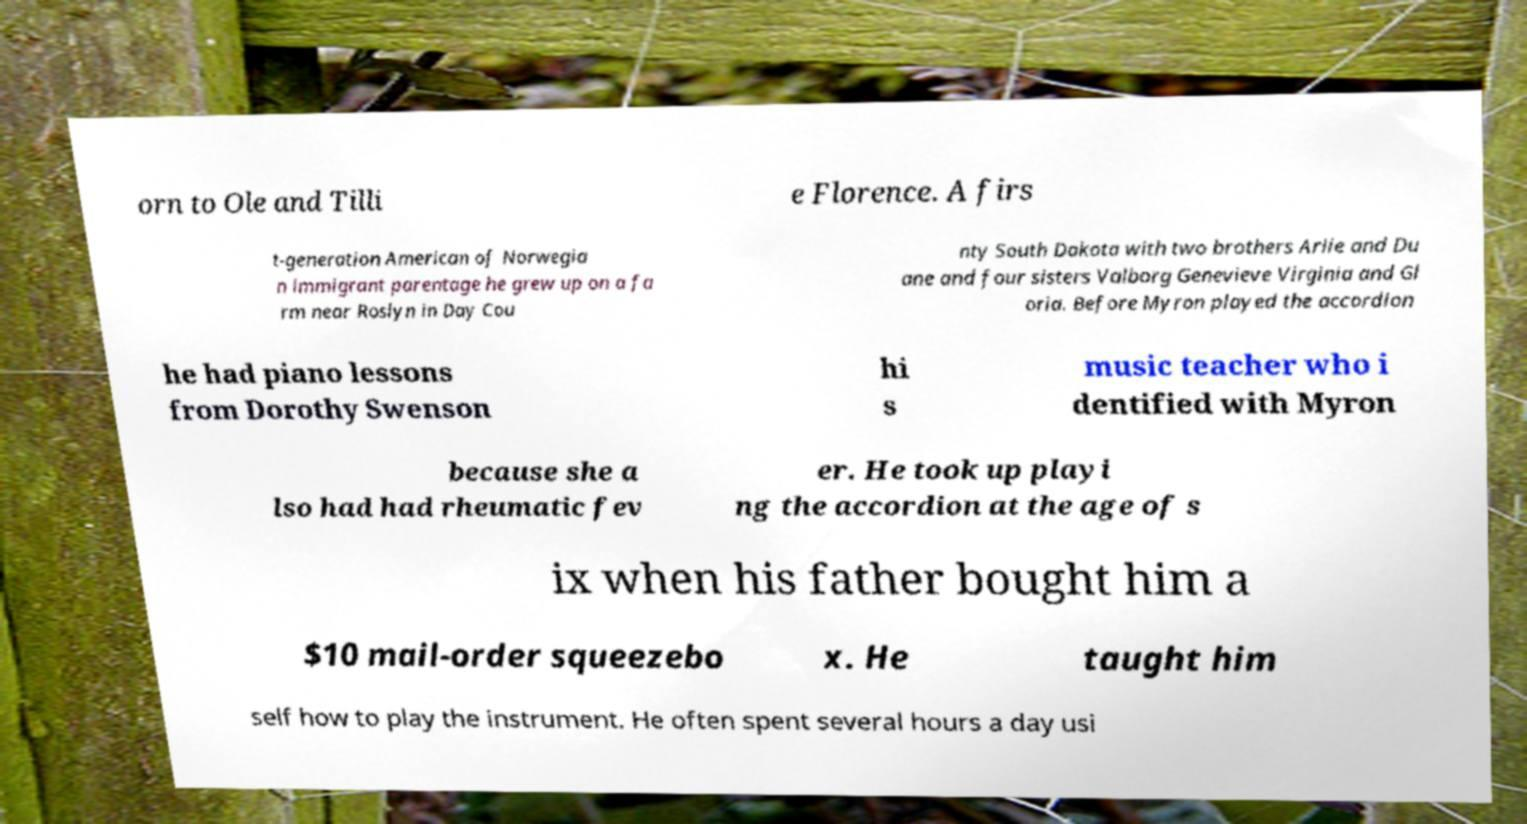Please read and relay the text visible in this image. What does it say? orn to Ole and Tilli e Florence. A firs t-generation American of Norwegia n immigrant parentage he grew up on a fa rm near Roslyn in Day Cou nty South Dakota with two brothers Arlie and Du ane and four sisters Valborg Genevieve Virginia and Gl oria. Before Myron played the accordion he had piano lessons from Dorothy Swenson hi s music teacher who i dentified with Myron because she a lso had had rheumatic fev er. He took up playi ng the accordion at the age of s ix when his father bought him a $10 mail-order squeezebo x. He taught him self how to play the instrument. He often spent several hours a day usi 